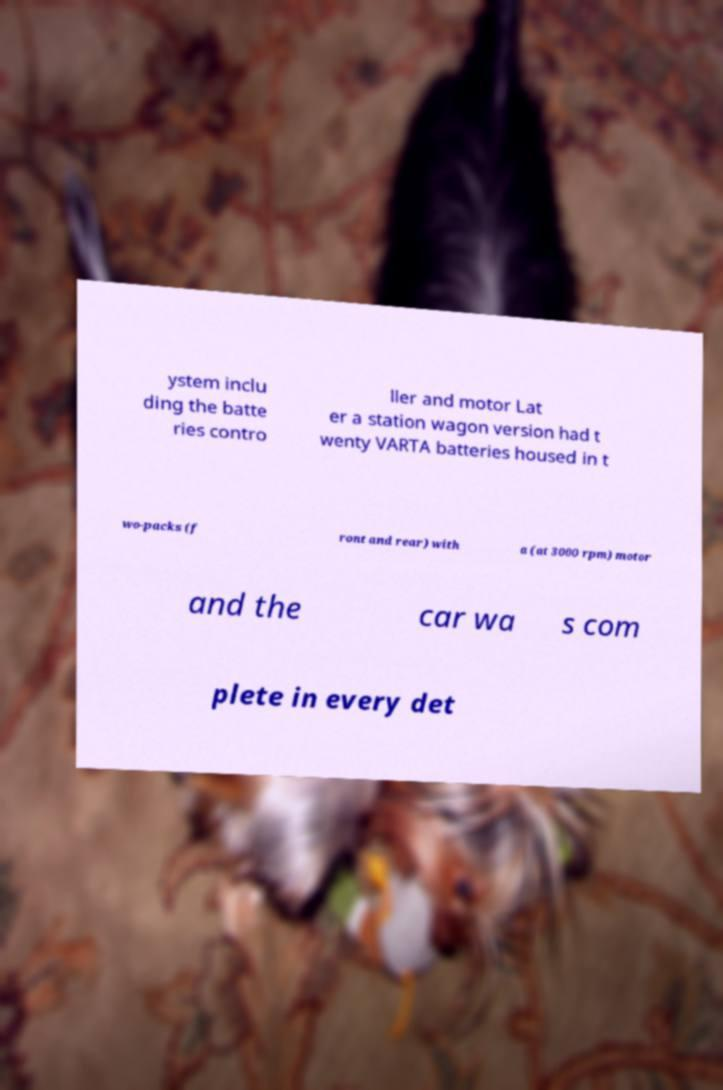Please identify and transcribe the text found in this image. ystem inclu ding the batte ries contro ller and motor Lat er a station wagon version had t wenty VARTA batteries housed in t wo-packs (f ront and rear) with a (at 3000 rpm) motor and the car wa s com plete in every det 